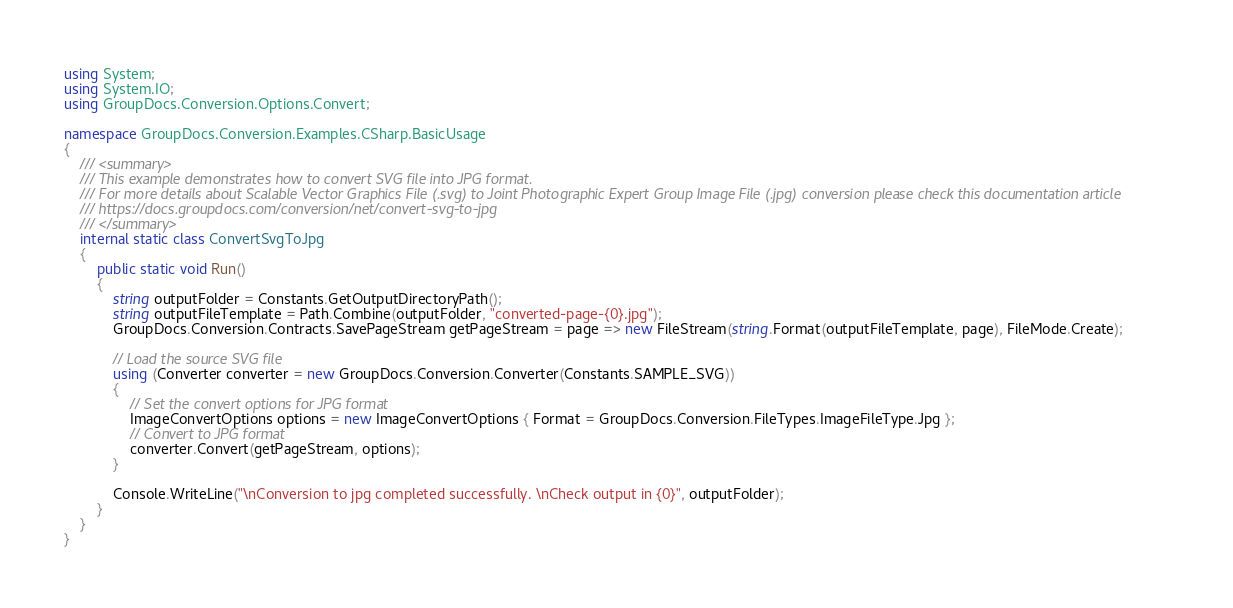Convert code to text. <code><loc_0><loc_0><loc_500><loc_500><_C#_>using System;
using System.IO;
using GroupDocs.Conversion.Options.Convert;

namespace GroupDocs.Conversion.Examples.CSharp.BasicUsage
{
    /// <summary>
    /// This example demonstrates how to convert SVG file into JPG format.
    /// For more details about Scalable Vector Graphics File (.svg) to Joint Photographic Expert Group Image File (.jpg) conversion please check this documentation article 
    /// https://docs.groupdocs.com/conversion/net/convert-svg-to-jpg
    /// </summary>
    internal static class ConvertSvgToJpg
    {
        public static void Run()
        {
            string outputFolder = Constants.GetOutputDirectoryPath();
            string outputFileTemplate = Path.Combine(outputFolder, "converted-page-{0}.jpg");
            GroupDocs.Conversion.Contracts.SavePageStream getPageStream = page => new FileStream(string.Format(outputFileTemplate, page), FileMode.Create);

            // Load the source SVG file
            using (Converter converter = new GroupDocs.Conversion.Converter(Constants.SAMPLE_SVG))
            {
                // Set the convert options for JPG format
                ImageConvertOptions options = new ImageConvertOptions { Format = GroupDocs.Conversion.FileTypes.ImageFileType.Jpg };  
                // Convert to JPG format
                converter.Convert(getPageStream, options);
            }

            Console.WriteLine("\nConversion to jpg completed successfully. \nCheck output in {0}", outputFolder);
        }
    }
}</code> 